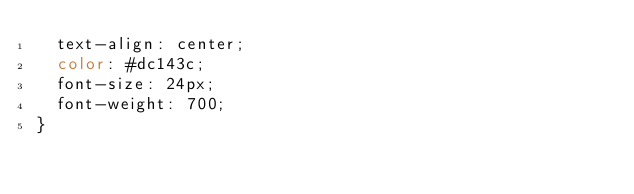Convert code to text. <code><loc_0><loc_0><loc_500><loc_500><_CSS_>  text-align: center;
  color: #dc143c;
  font-size: 24px;
  font-weight: 700;
}
</code> 